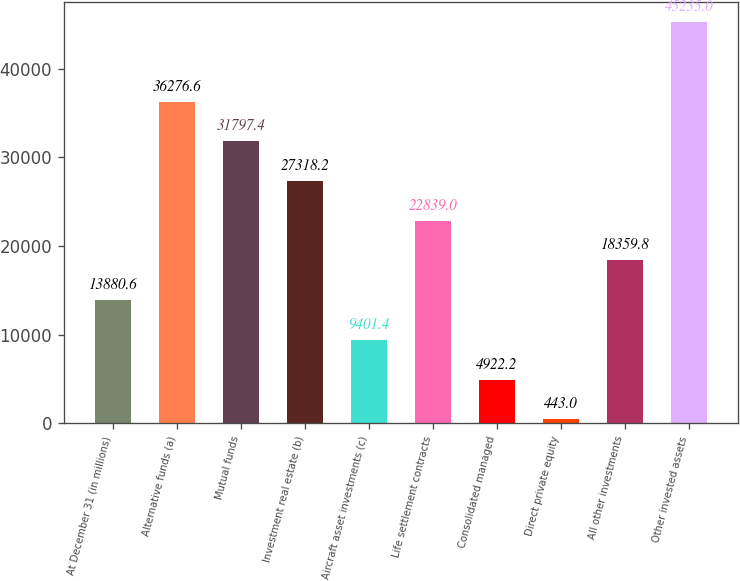Convert chart to OTSL. <chart><loc_0><loc_0><loc_500><loc_500><bar_chart><fcel>At December 31 (in millions)<fcel>Alternative funds (a)<fcel>Mutual funds<fcel>Investment real estate (b)<fcel>Aircraft asset investments (c)<fcel>Life settlement contracts<fcel>Consolidated managed<fcel>Direct private equity<fcel>All other investments<fcel>Other invested assets<nl><fcel>13880.6<fcel>36276.6<fcel>31797.4<fcel>27318.2<fcel>9401.4<fcel>22839<fcel>4922.2<fcel>443<fcel>18359.8<fcel>45235<nl></chart> 